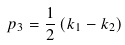Convert formula to latex. <formula><loc_0><loc_0><loc_500><loc_500>p _ { 3 } = \frac { 1 } { 2 } \left ( k _ { 1 } - k _ { 2 } \right )</formula> 